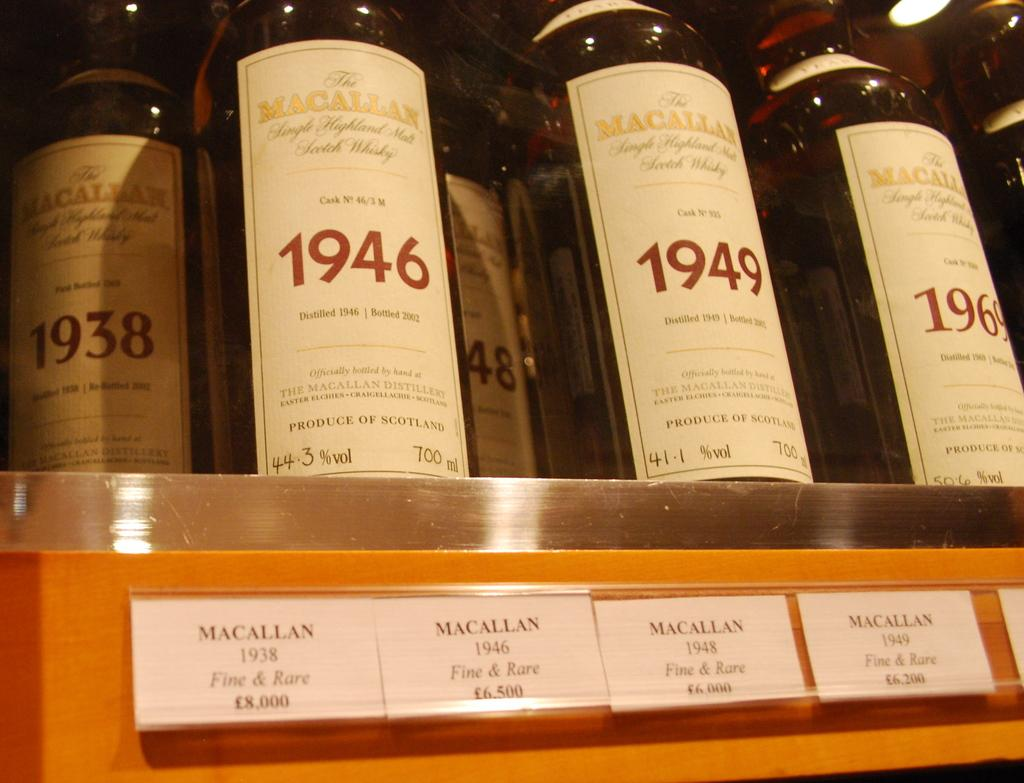<image>
Create a compact narrative representing the image presented. Several bottles of different wines sit next to each other with different dates like 1946 or 1969 on them. 